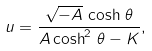<formula> <loc_0><loc_0><loc_500><loc_500>u = \frac { \sqrt { - A } \, \cosh \, \theta } { A \cosh ^ { 2 } \, \theta - K } ,</formula> 